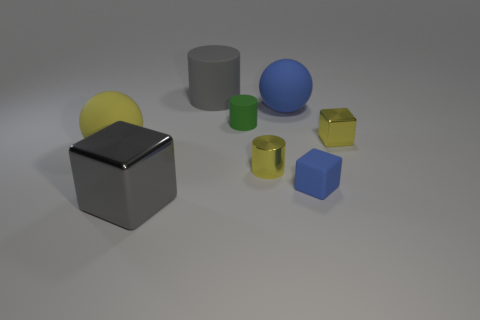Add 1 small yellow metallic things. How many objects exist? 9 Subtract all yellow metal cylinders. How many cylinders are left? 2 Subtract 1 blocks. How many blocks are left? 2 Subtract all yellow cylinders. How many cylinders are left? 2 Add 6 gray cylinders. How many gray cylinders exist? 7 Subtract 0 brown cylinders. How many objects are left? 8 Subtract all balls. How many objects are left? 6 Subtract all blue spheres. Subtract all green blocks. How many spheres are left? 1 Subtract all purple cylinders. Subtract all large metallic cubes. How many objects are left? 7 Add 1 yellow metallic cylinders. How many yellow metallic cylinders are left? 2 